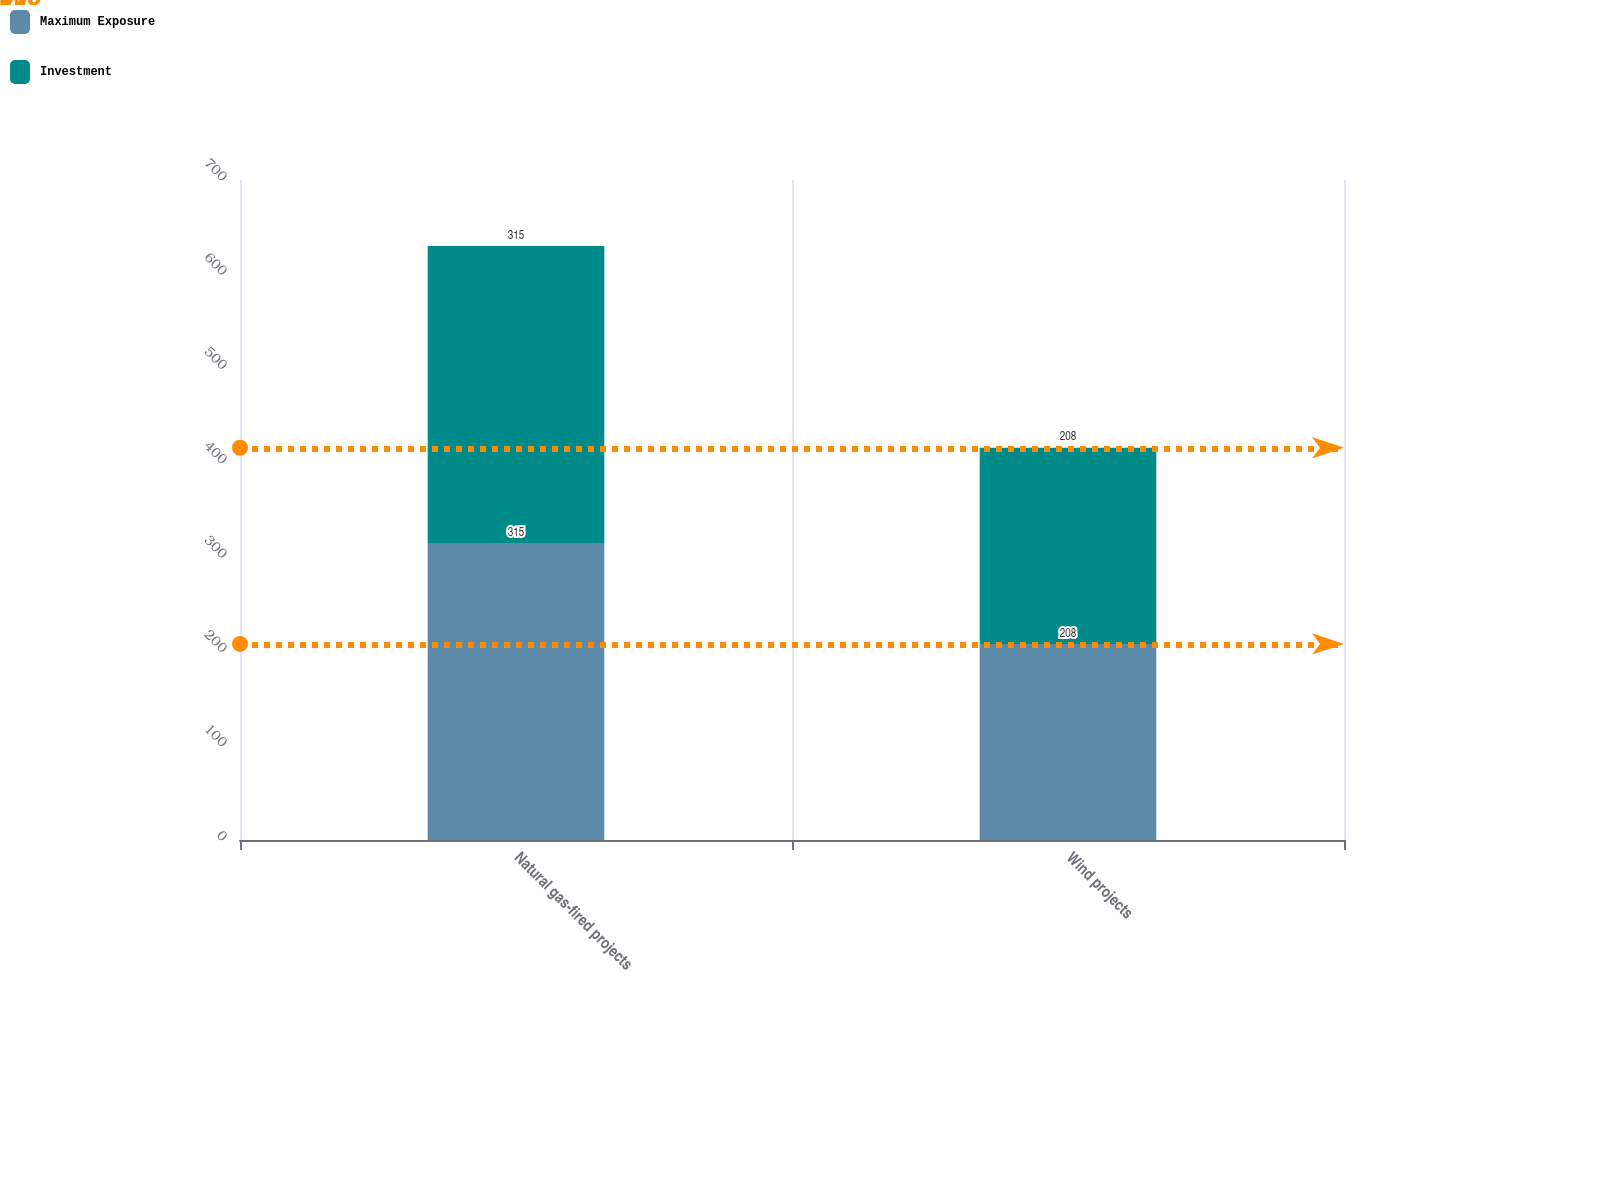<chart> <loc_0><loc_0><loc_500><loc_500><stacked_bar_chart><ecel><fcel>Natural gas-fired projects<fcel>Wind projects<nl><fcel>Maximum Exposure<fcel>315<fcel>208<nl><fcel>Investment<fcel>315<fcel>208<nl></chart> 